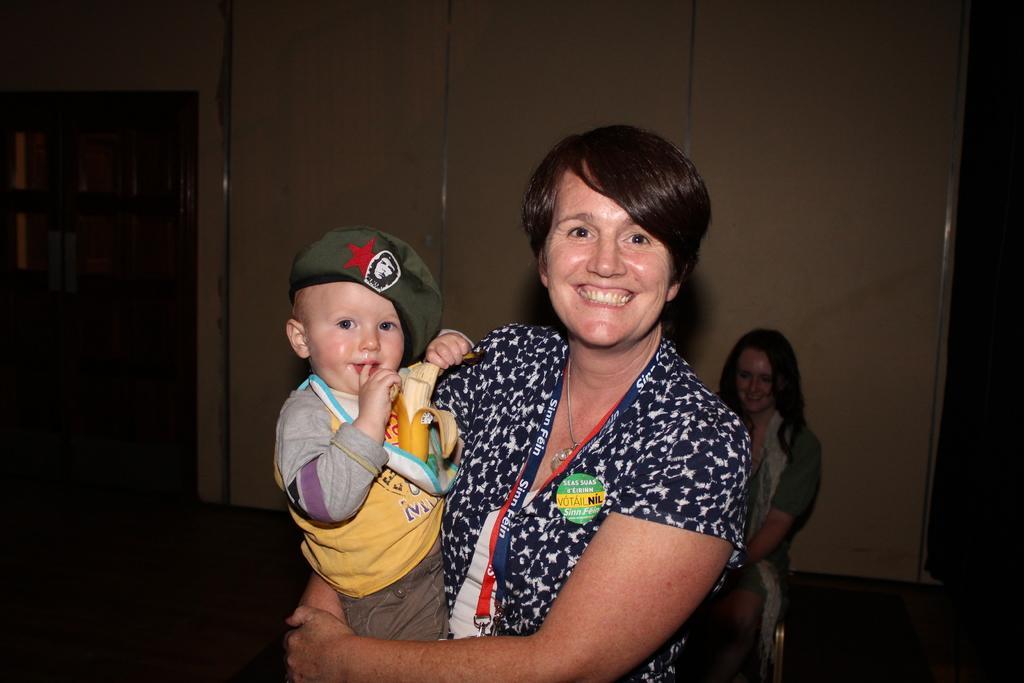Please provide a concise description of this image. In this image, we can see a lady smiling and holding a kid and wearing an id card. In the background, there is an another lady sitting on the chair and we can see a door and there is a wall. 